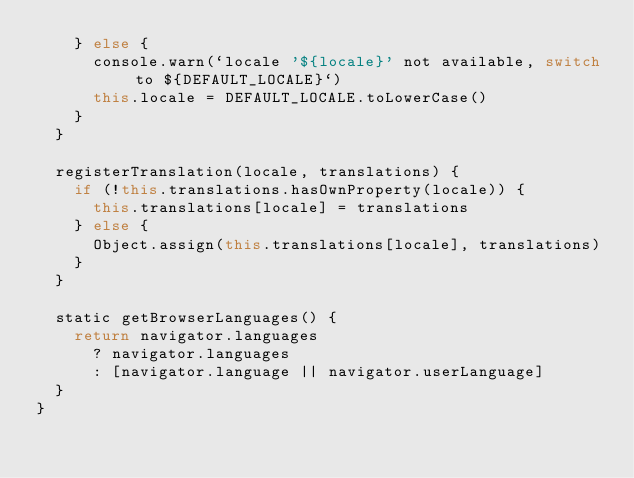Convert code to text. <code><loc_0><loc_0><loc_500><loc_500><_JavaScript_>    } else {
      console.warn(`locale '${locale}' not available, switch to ${DEFAULT_LOCALE}`)
      this.locale = DEFAULT_LOCALE.toLowerCase()
    }
  }

  registerTranslation(locale, translations) {
    if (!this.translations.hasOwnProperty(locale)) {
      this.translations[locale] = translations
    } else {
      Object.assign(this.translations[locale], translations)
    }
  }

  static getBrowserLanguages() {
    return navigator.languages
      ? navigator.languages
      : [navigator.language || navigator.userLanguage]
  }
}
</code> 